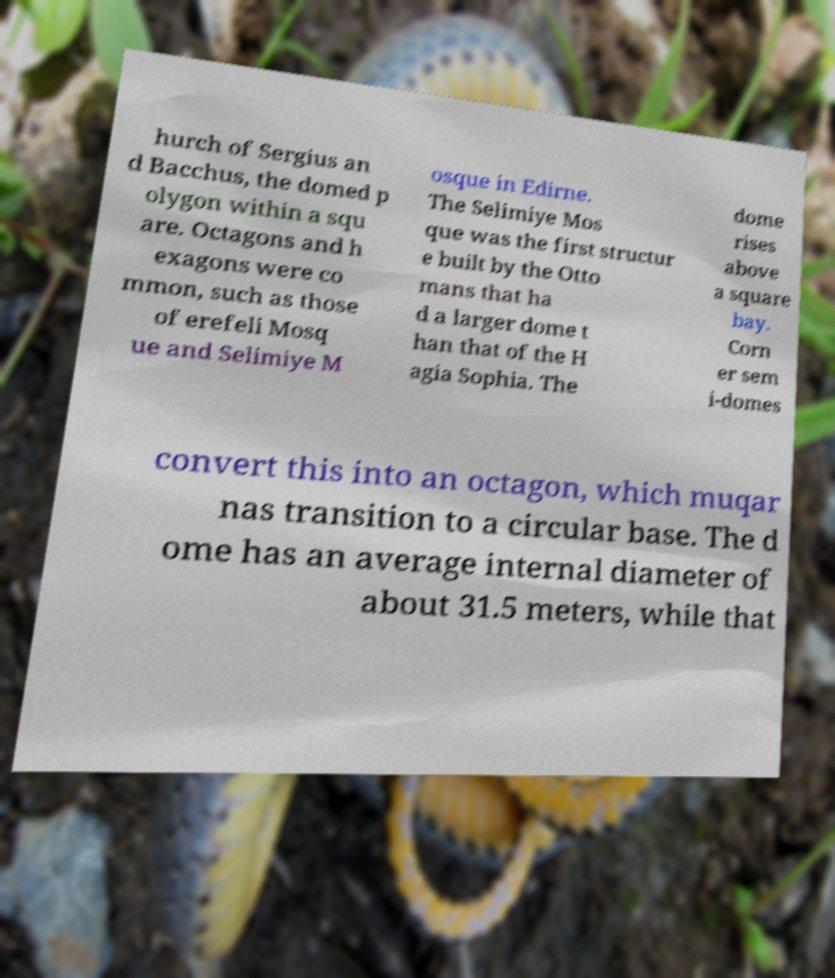Please identify and transcribe the text found in this image. hurch of Sergius an d Bacchus, the domed p olygon within a squ are. Octagons and h exagons were co mmon, such as those of erefeli Mosq ue and Selimiye M osque in Edirne. The Selimiye Mos que was the first structur e built by the Otto mans that ha d a larger dome t han that of the H agia Sophia. The dome rises above a square bay. Corn er sem i-domes convert this into an octagon, which muqar nas transition to a circular base. The d ome has an average internal diameter of about 31.5 meters, while that 